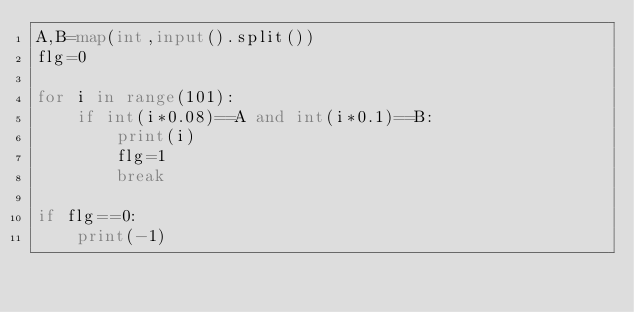<code> <loc_0><loc_0><loc_500><loc_500><_Python_>A,B=map(int,input().split())
flg=0

for i in range(101):
    if int(i*0.08)==A and int(i*0.1)==B:
        print(i)
        flg=1
        break

if flg==0:
    print(-1)</code> 